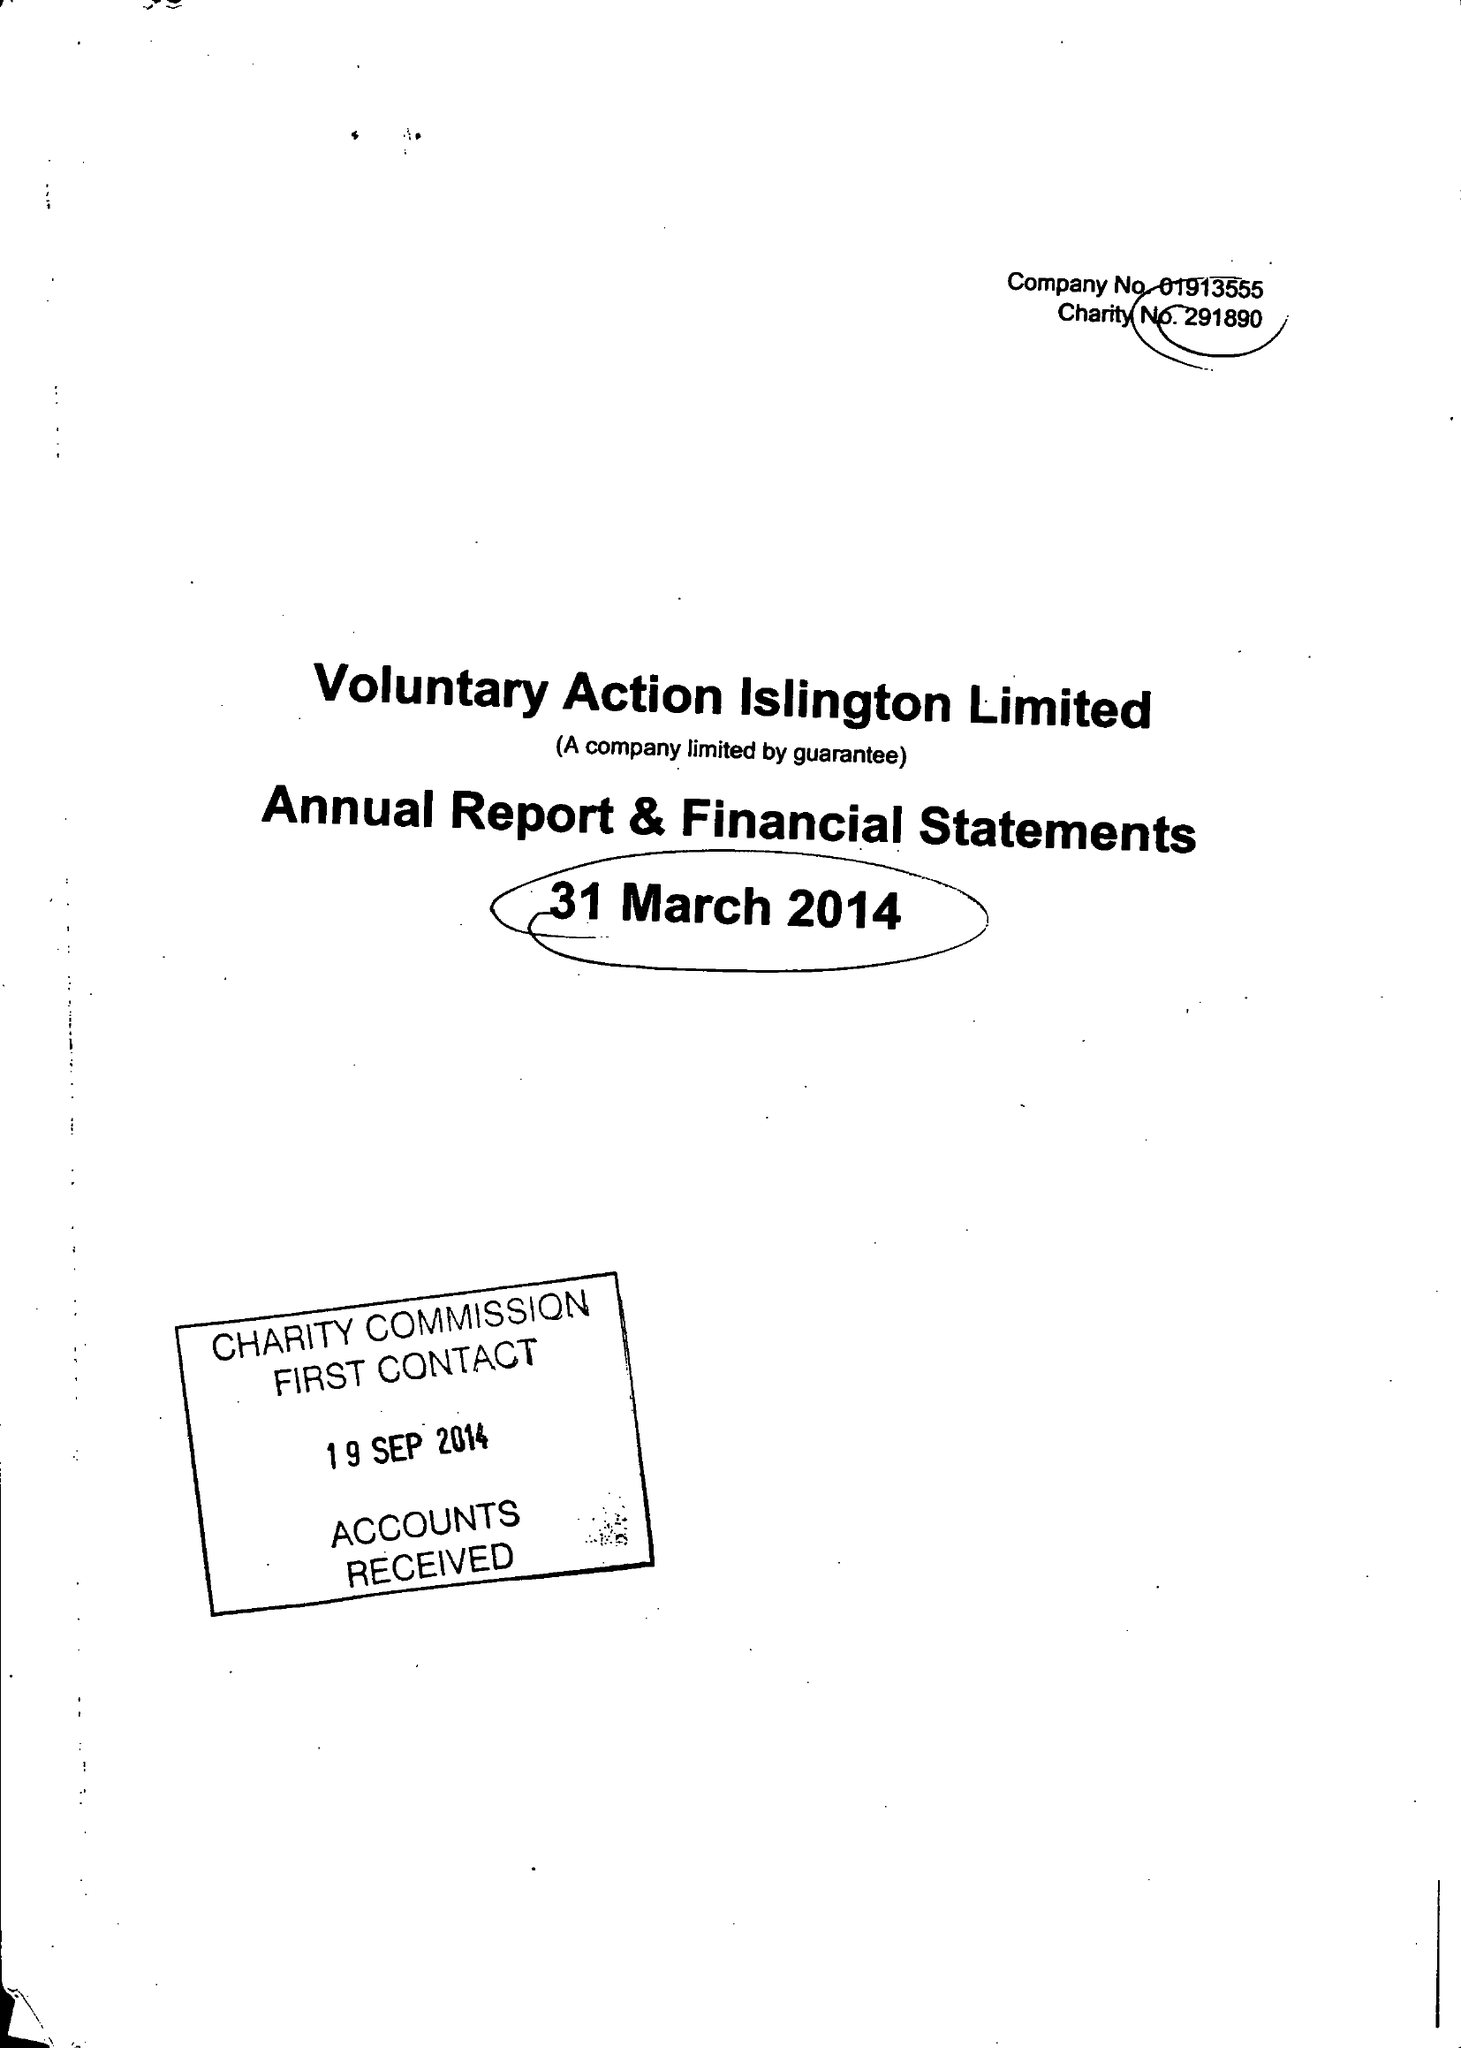What is the value for the address__post_town?
Answer the question using a single word or phrase. LONDON 